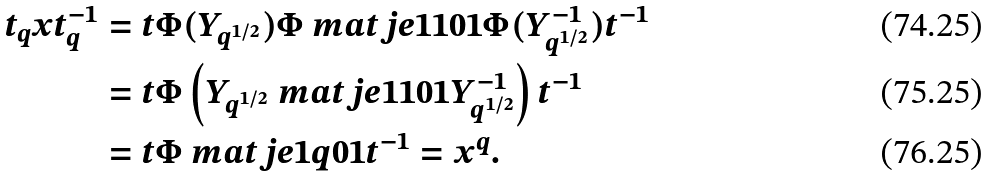Convert formula to latex. <formula><loc_0><loc_0><loc_500><loc_500>t _ { q } x t _ { q } ^ { - 1 } & = t \Phi ( Y _ { q ^ { 1 / 2 } } ) \Phi \ m a t j e { 1 } { 1 } { 0 } { 1 } \Phi ( Y _ { q ^ { 1 / 2 } } ^ { - 1 } ) t ^ { - 1 } \\ & = t \Phi \left ( Y _ { q ^ { 1 / 2 } } \ m a t j e { 1 } { 1 } { 0 } { 1 } Y _ { q ^ { 1 / 2 } } ^ { - 1 } \right ) t ^ { - 1 } \\ & = t \Phi \ m a t j e { 1 } { q } { 0 } { 1 } t ^ { - 1 } = x ^ { q } .</formula> 